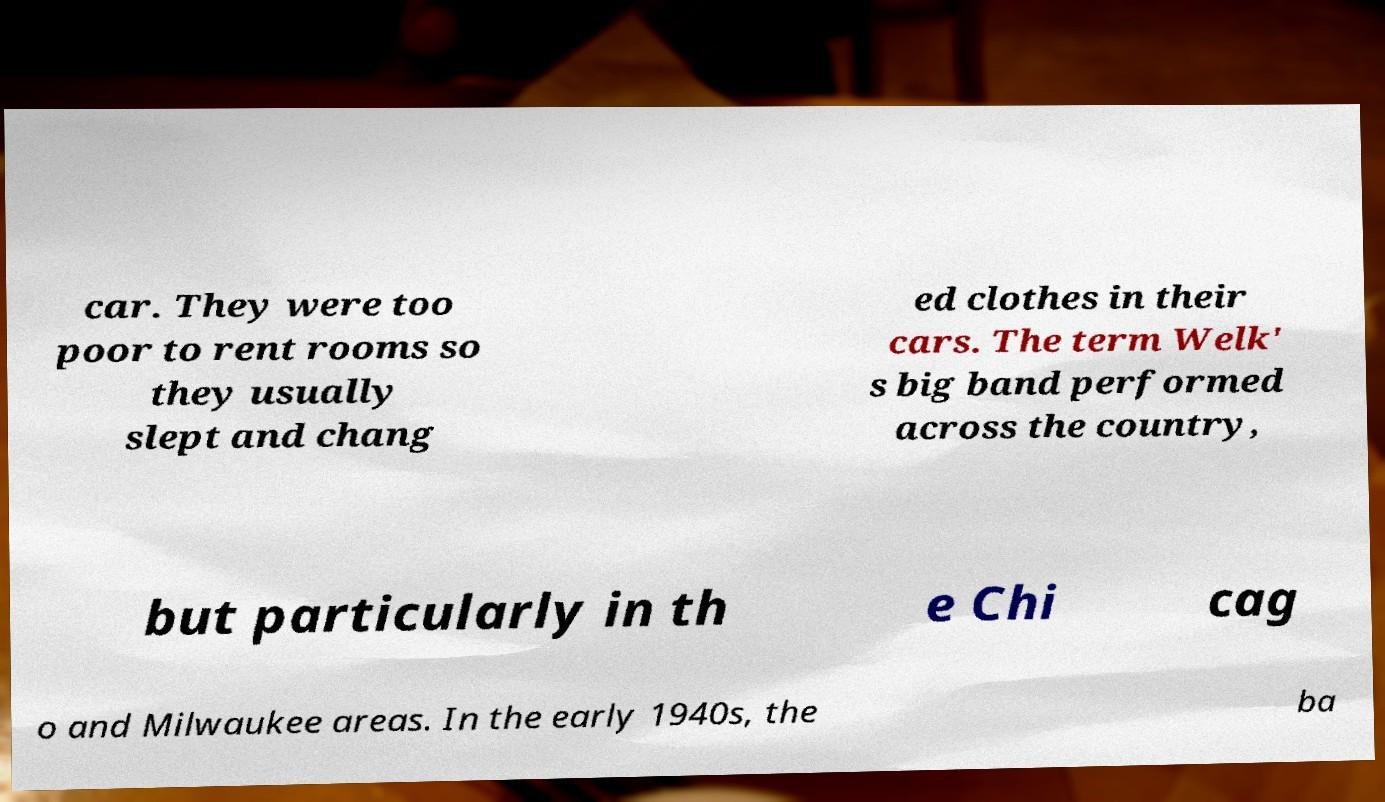Could you extract and type out the text from this image? car. They were too poor to rent rooms so they usually slept and chang ed clothes in their cars. The term Welk' s big band performed across the country, but particularly in th e Chi cag o and Milwaukee areas. In the early 1940s, the ba 